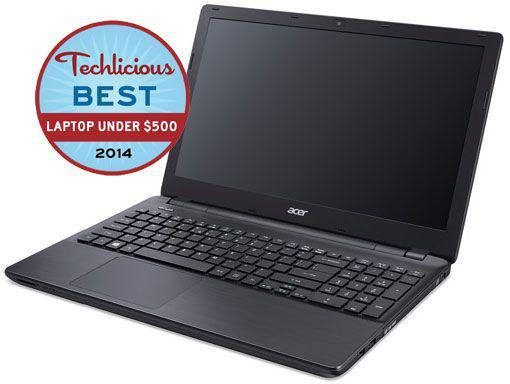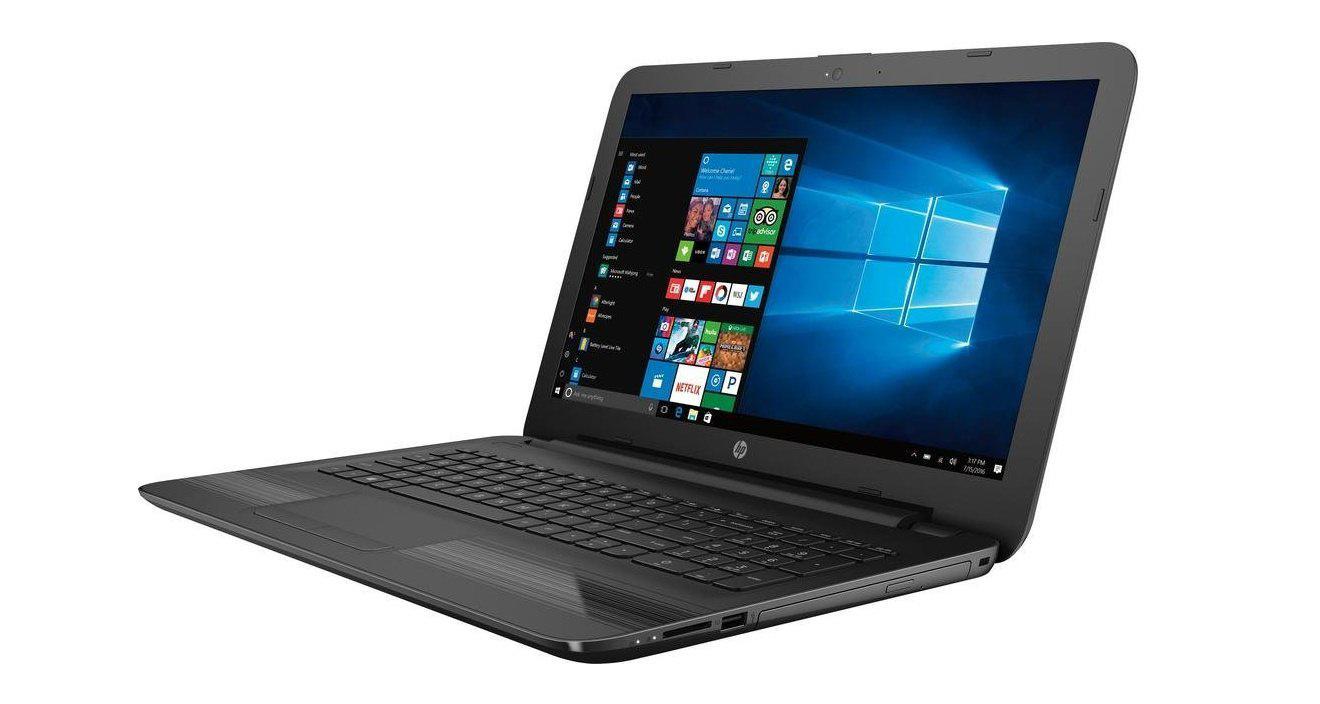The first image is the image on the left, the second image is the image on the right. Examine the images to the left and right. Is the description "The left image contains one leftward-facing open laptop with a mostly black screen, and the right image contains one leftward-facing laptop with a mostly blue screen." accurate? Answer yes or no. Yes. The first image is the image on the left, the second image is the image on the right. Assess this claim about the two images: "In at least one image there is an open laptop with a blue background, thats bottom is silver and frame around the screen is black.". Correct or not? Answer yes or no. No. 